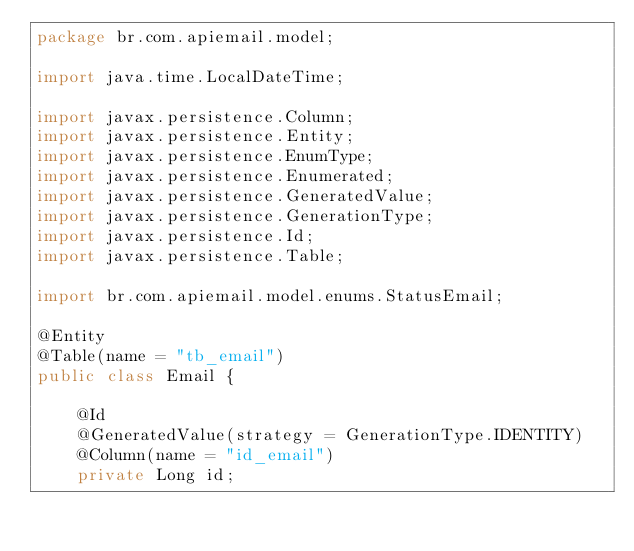<code> <loc_0><loc_0><loc_500><loc_500><_Java_>package br.com.apiemail.model;

import java.time.LocalDateTime;

import javax.persistence.Column;
import javax.persistence.Entity;
import javax.persistence.EnumType;
import javax.persistence.Enumerated;
import javax.persistence.GeneratedValue;
import javax.persistence.GenerationType;
import javax.persistence.Id;
import javax.persistence.Table;

import br.com.apiemail.model.enums.StatusEmail;

@Entity
@Table(name = "tb_email")
public class Email {
	
	@Id
	@GeneratedValue(strategy = GenerationType.IDENTITY)
	@Column(name = "id_email")
	private Long id;</code> 